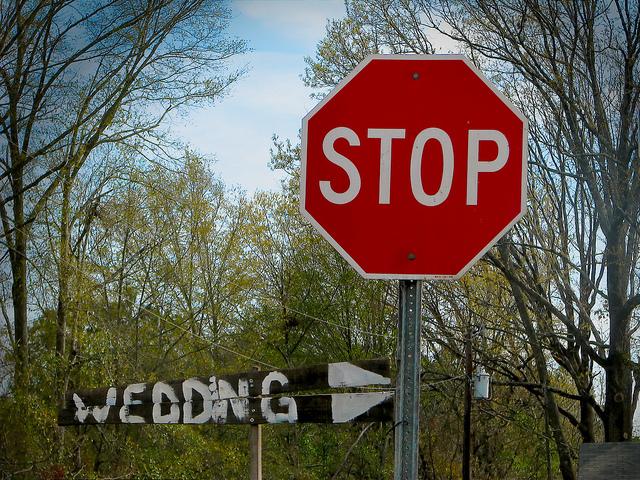What shape is the sign?
Short answer required. Octagon. How many signs are there?
Quick response, please. 2. What color is the sign?
Give a very brief answer. Red. 